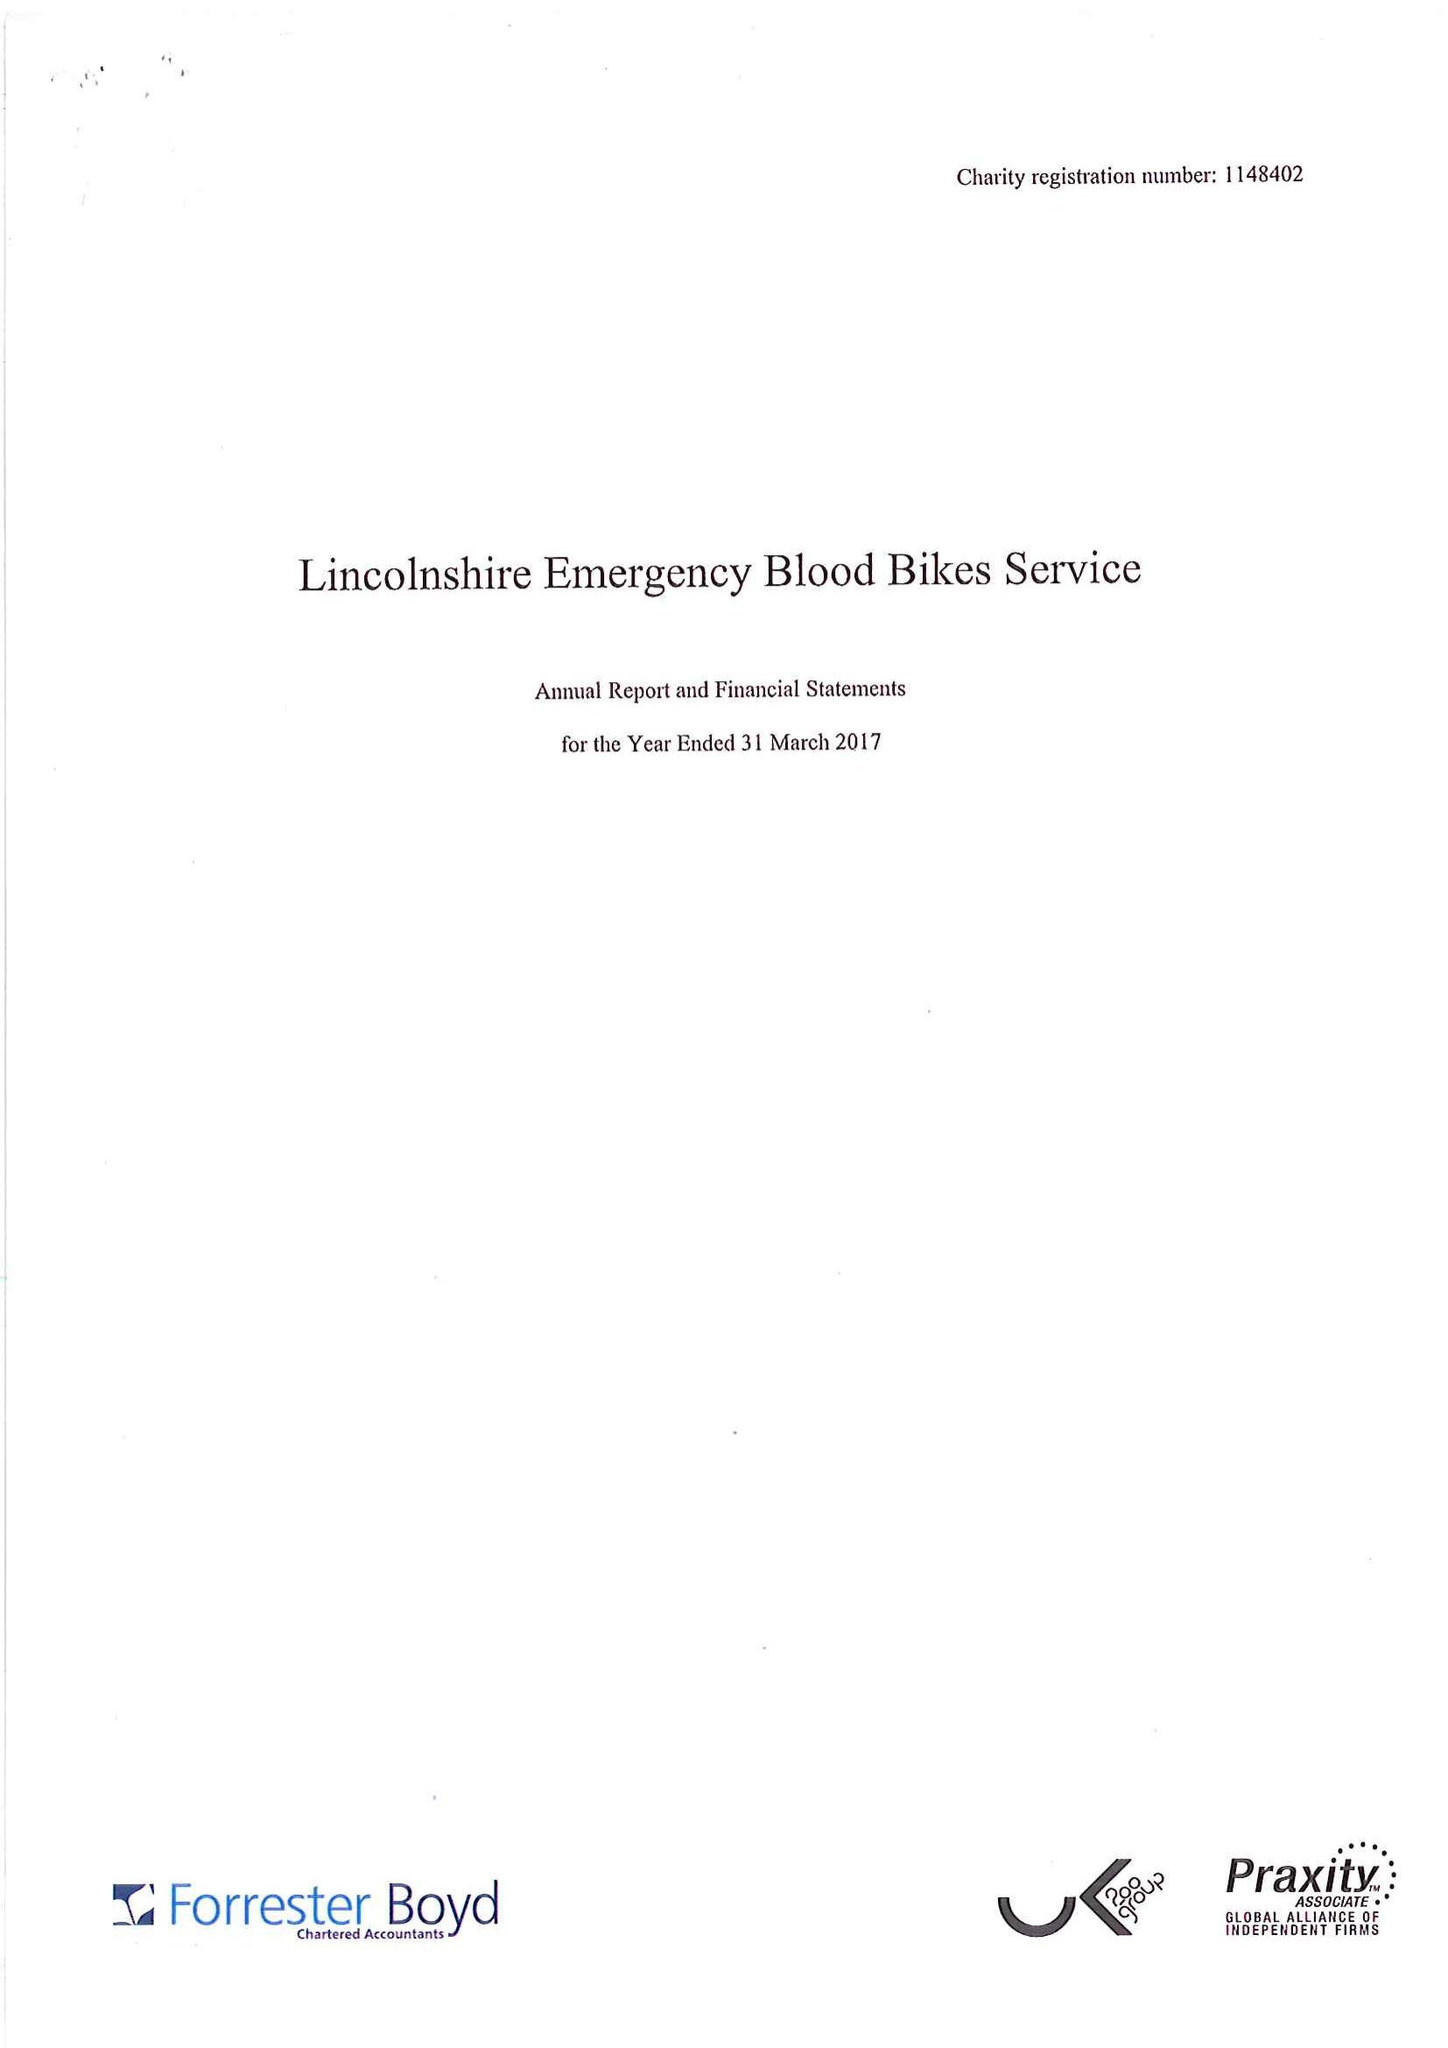What is the value for the address__post_town?
Answer the question using a single word or phrase. LOUTH 